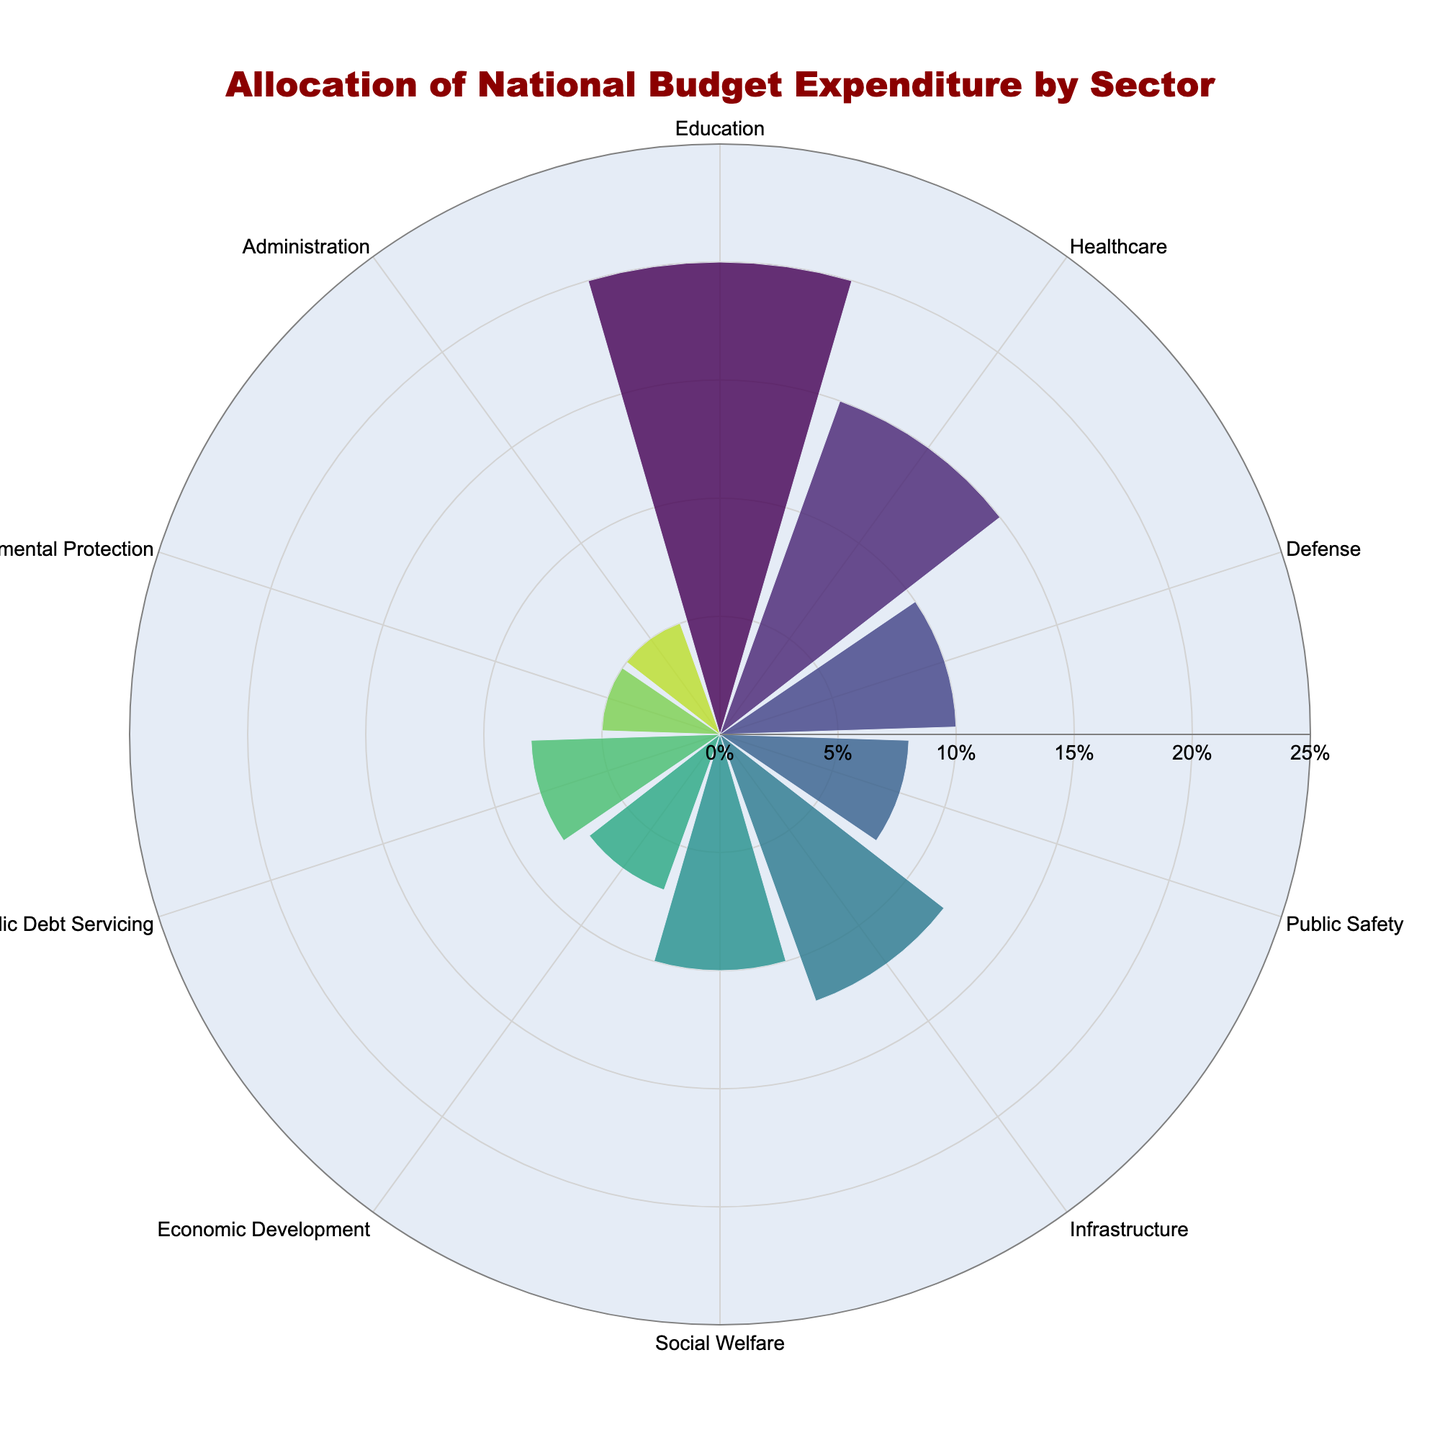What is the combined percentage of the national budget for Public Safety and Public Debt Servicing? The chart shows Public Safety with 8% and Public Debt Servicing also with 8%. Adding these two percentages gives 8% + 8% = 16%.
Answer: 16% Which sectors receive equal percentages of the national budget? By scanning the chart, Social Welfare and Defense have equal percentages of 10%, and Public Safety and Public Debt Servicing both have 8%.
Answer: Social Welfare and Defense; Public Safety and Public Debt Servicing How much more is allocated to Healthcare than to Environmental Protection? The chart shows Healthcare at 15% and Environmental Protection at 5%. The difference is 15% - 5% = 10%.
Answer: 10% What is the average allocation percentage across all sectors? Adding all the percentages: 20 + 15 + 10 + 8 + 12 + 10 + 7 + 8 + 5 + 5 = 100%. Dividing by the number of sectors (10) gives 100 / 10 = 10%.
Answer: 10% Is the allocation for Infrastructure greater than for Economic Development? The chart shows Infrastructure at 12% and Economic Development at 7%. Comparing these two values, 12% > 7%.
Answer: Yes Which three sectors have the smallest percentages of the national budget allocation? The smallest bars in the chart are Environmental Protection and Administration, both at 5%, and Economic Development at 7%.
Answer: Environmental Protection, Administration, and Economic Development Is there any sector with exactly twice the allocation of another sector? Upon inspecting the chart, Administration and Environmental Protection each have 5%, which is exactly half of Healthcare's 15%.
Answer: Yes, Healthcare is twice the Administration and Environmental Protection What percentage of the budget is allocated to non-social sectors (excluding Education, Healthcare, Social Welfare, and Public Safety)? Exclude Education (20%), Healthcare (15%), Social Welfare (10%), and Public Safety (8%). The remaining sectors' percentages are: Defense (10), Infrastructure (12), Economic Development (7), Public Debt Servicing (8), Environmental Protection (5), Administration (5). Adding these: 10 + 12 + 7 + 8 + 5 + 5 = 47%.
Answer: 47% 